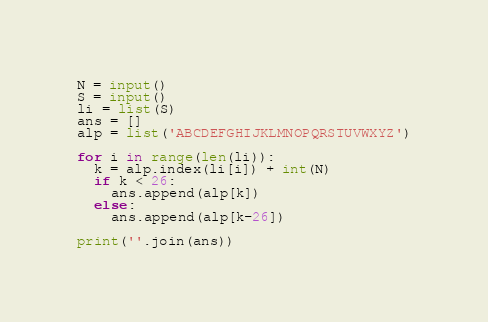<code> <loc_0><loc_0><loc_500><loc_500><_Python_>N = input()
S = input()
li = list(S)
ans = []
alp = list('ABCDEFGHIJKLMNOPQRSTUVWXYZ')

for i in range(len(li)):
  k = alp.index(li[i]) + int(N)
  if k < 26:
    ans.append(alp[k])
  else:
    ans.append(alp[k-26])
 
print(''.join(ans))</code> 